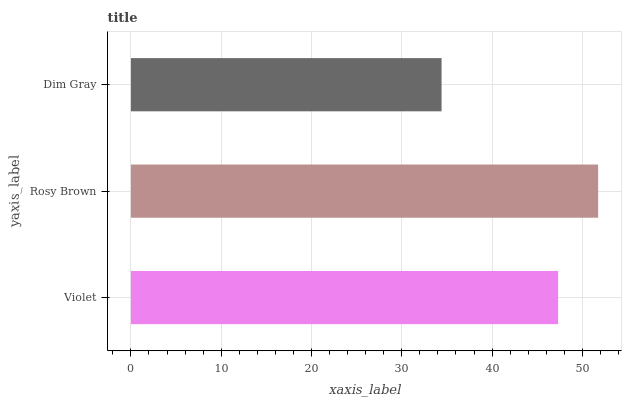Is Dim Gray the minimum?
Answer yes or no. Yes. Is Rosy Brown the maximum?
Answer yes or no. Yes. Is Rosy Brown the minimum?
Answer yes or no. No. Is Dim Gray the maximum?
Answer yes or no. No. Is Rosy Brown greater than Dim Gray?
Answer yes or no. Yes. Is Dim Gray less than Rosy Brown?
Answer yes or no. Yes. Is Dim Gray greater than Rosy Brown?
Answer yes or no. No. Is Rosy Brown less than Dim Gray?
Answer yes or no. No. Is Violet the high median?
Answer yes or no. Yes. Is Violet the low median?
Answer yes or no. Yes. Is Dim Gray the high median?
Answer yes or no. No. Is Rosy Brown the low median?
Answer yes or no. No. 